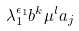Convert formula to latex. <formula><loc_0><loc_0><loc_500><loc_500>\lambda _ { 1 } ^ { \epsilon _ { 1 } } b ^ { k } \mu ^ { l } a _ { j }</formula> 